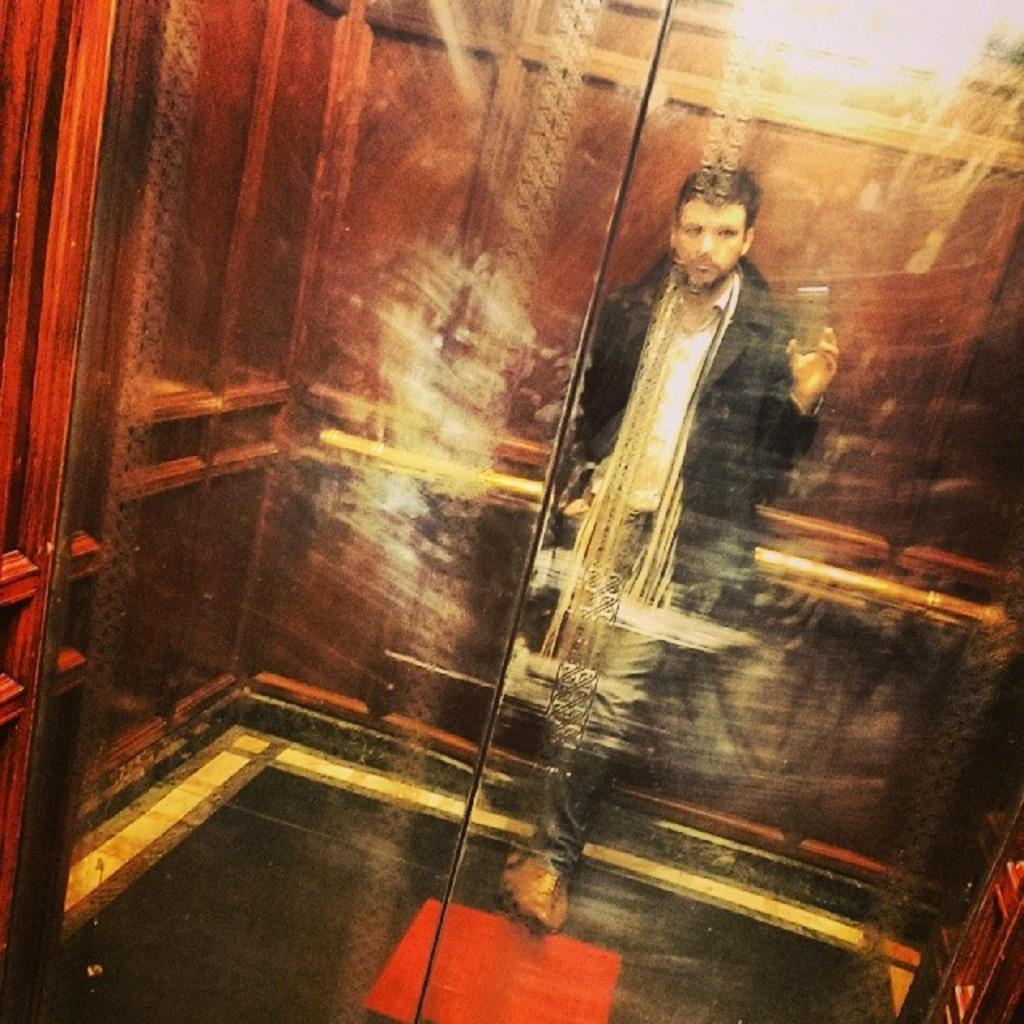What object is visible in the image that can hold a liquid? There is a glass in the image. What can be seen in the glass's reflection? The glass reflects a person standing. What is the person holding in the image? The person is holding a mobile phone. What type of lunch is the giraffe eating in the image? There is no giraffe present in the image, so it is not possible to determine what type of lunch it might be eating. 